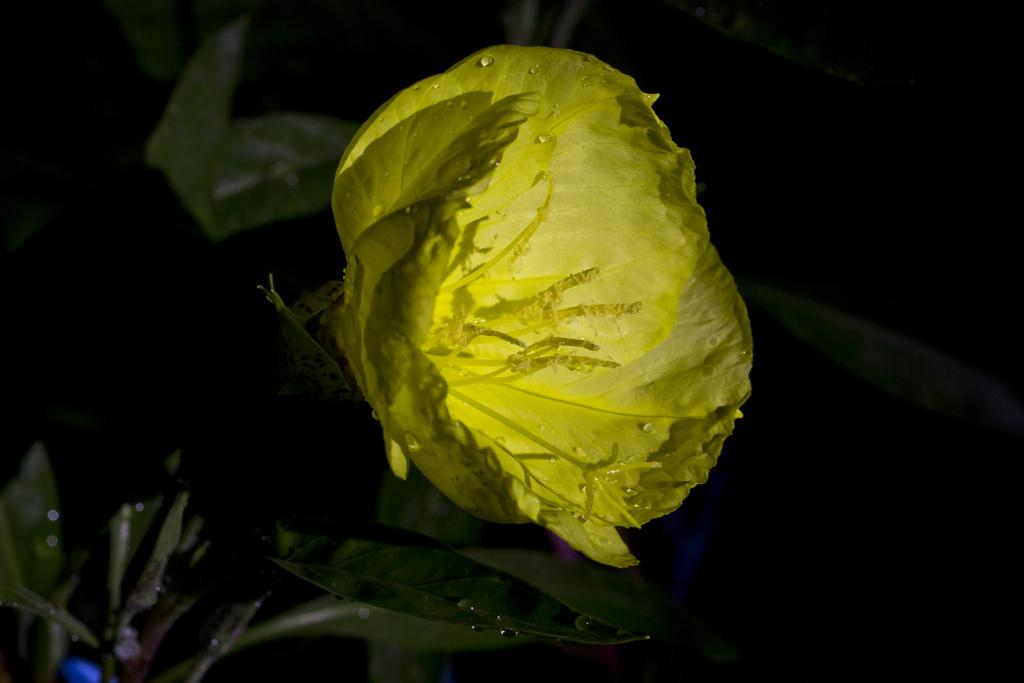What color is the flower on the plant in the image? The flower on the plant is yellow. What can be seen on the right side of the image? There is darkness on the right side of the image. What else is visible at the bottom of the image besides the flower? There are leaves visible at the bottom of the image. Can you describe the berry that is flying in the image? There is no berry present in the image, nor is there any indication of flight. 